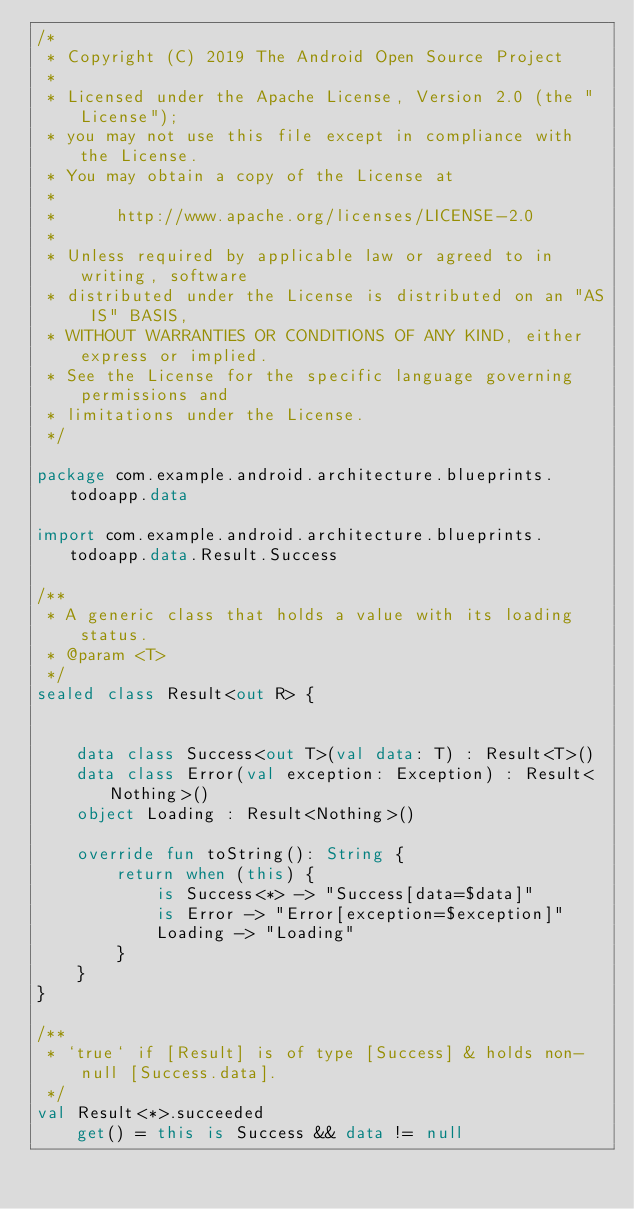Convert code to text. <code><loc_0><loc_0><loc_500><loc_500><_Kotlin_>/*
 * Copyright (C) 2019 The Android Open Source Project
 *
 * Licensed under the Apache License, Version 2.0 (the "License");
 * you may not use this file except in compliance with the License.
 * You may obtain a copy of the License at
 *
 *      http://www.apache.org/licenses/LICENSE-2.0
 *
 * Unless required by applicable law or agreed to in writing, software
 * distributed under the License is distributed on an "AS IS" BASIS,
 * WITHOUT WARRANTIES OR CONDITIONS OF ANY KIND, either express or implied.
 * See the License for the specific language governing permissions and
 * limitations under the License.
 */

package com.example.android.architecture.blueprints.todoapp.data

import com.example.android.architecture.blueprints.todoapp.data.Result.Success

/**
 * A generic class that holds a value with its loading status.
 * @param <T>
 */
sealed class Result<out R> {


    data class Success<out T>(val data: T) : Result<T>()
    data class Error(val exception: Exception) : Result<Nothing>()
    object Loading : Result<Nothing>()

    override fun toString(): String {
        return when (this) {
            is Success<*> -> "Success[data=$data]"
            is Error -> "Error[exception=$exception]"
            Loading -> "Loading"
        }
    }
}

/**
 * `true` if [Result] is of type [Success] & holds non-null [Success.data].
 */
val Result<*>.succeeded
    get() = this is Success && data != null
</code> 